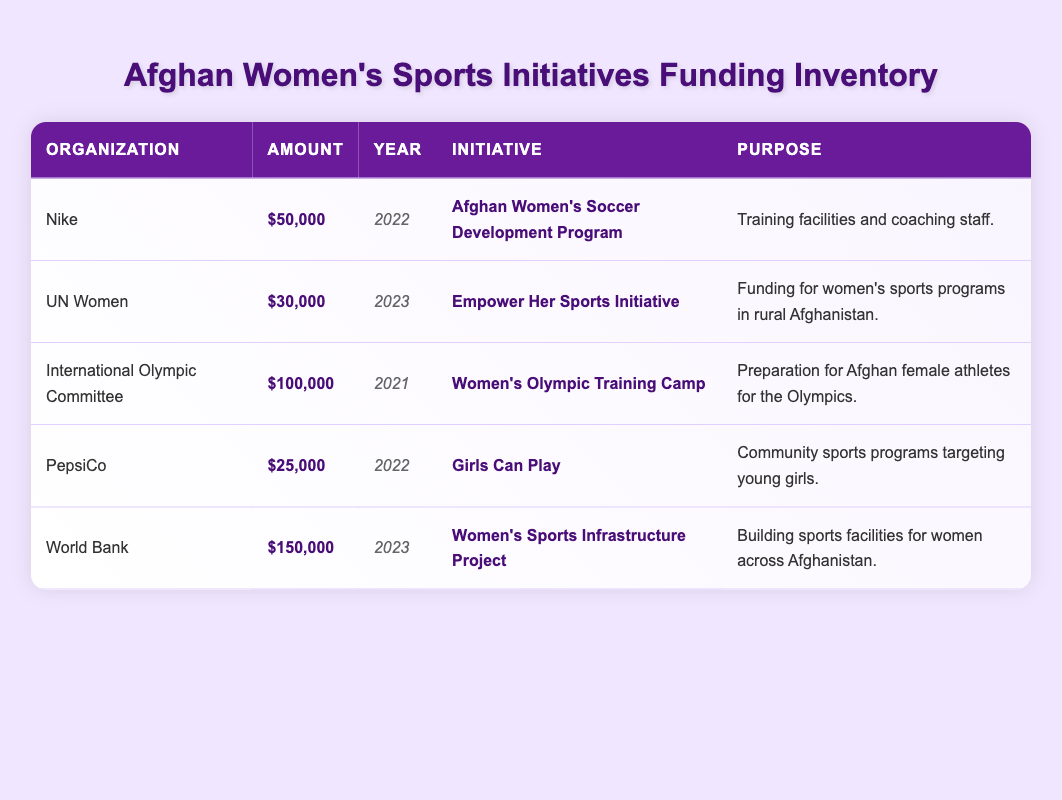What is the total funding received from Nike? According to the table, the funding received from Nike is listed as $50,000 for the Afghan Women's Soccer Development Program in 2022. Therefore, the total amount is simply the amount stated in the table.
Answer: 50000 Which organization funded the Women's Olympic Training Camp? From the table, the organization that funded the Women's Olympic Training Camp is the International Olympic Committee. This information is directly found in the row corresponding to this initiative.
Answer: International Olympic Committee What is the average amount of funding received across all initiatives? To find the average amount, add all the amounts together: 50000 + 30000 + 100000 + 25000 + 150000 = 350000. Then divide by the number of initiatives, which is 5. So, 350000 / 5 = 70000.
Answer: 70000 Did PepsiCo provide more funding than UN Women? From the table, PepsiCo provided $25,000 and UN Women provided $30,000. Since $25,000 is less than $30,000, the statement is false.
Answer: No What initiative received the highest funding, and who funded it? By reviewing the amounts in the table, the initiative with the highest funding is the Women’s Sports Infrastructure Project, which received $150,000 from the World Bank. This is determined by comparing each amount listed.
Answer: Women’s Sports Infrastructure Project, World Bank What is the total amount of funding received from organizations in 2023? In 2023, there are two entries: UN Women ($30,000) and World Bank ($150,000). Therefore, the total amount is 30000 + 150000 = 180000.
Answer: 180000 Is the purpose of the Girls Can Play initiative focused on adult women? The purpose of the Girls Can Play initiative is to target community sports programs for young girls, which indicates that it is not focused on adult women. The information is clearly stated in the table, thus confirming that it is targeted at a younger demographic.
Answer: No Which organization contributed the least amount in funding, and what was the initiative? Looking at the table, PepsiCo contributed the least amount of $25,000 for the initiative titled Girls Can Play. This is determined by comparing all amounts listed in the table.
Answer: PepsiCo, Girls Can Play 